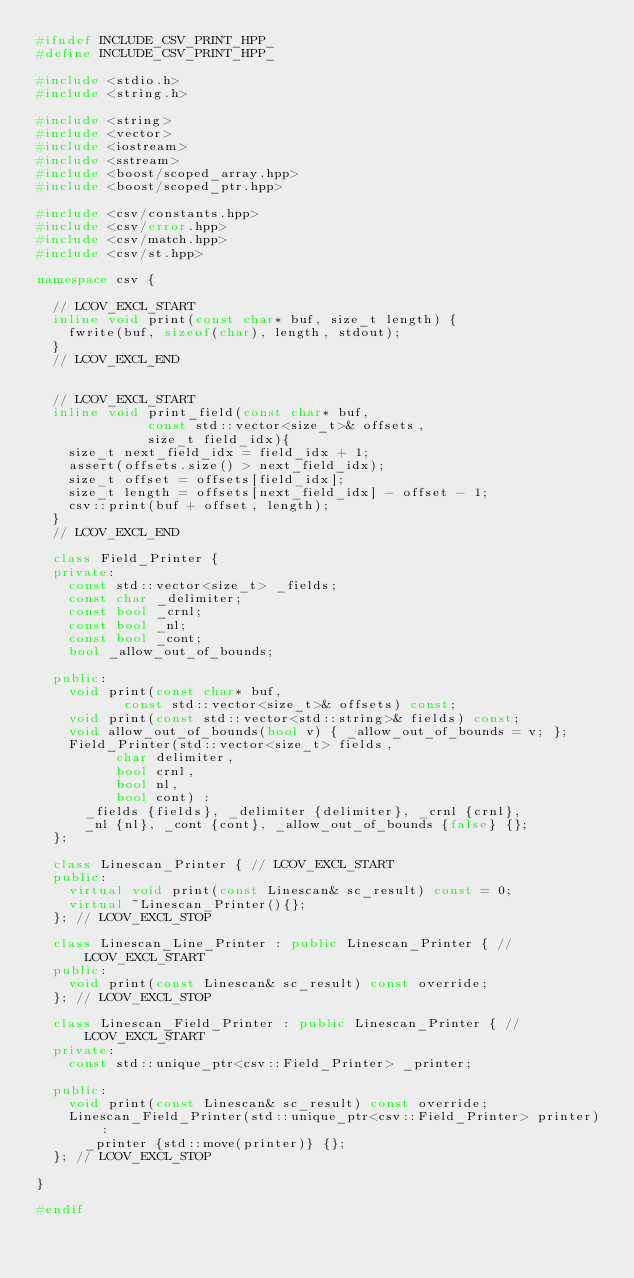Convert code to text. <code><loc_0><loc_0><loc_500><loc_500><_C++_>#ifndef INCLUDE_CSV_PRINT_HPP_
#define INCLUDE_CSV_PRINT_HPP_

#include <stdio.h>
#include <string.h>

#include <string>
#include <vector>
#include <iostream>
#include <sstream>
#include <boost/scoped_array.hpp>
#include <boost/scoped_ptr.hpp>

#include <csv/constants.hpp>
#include <csv/error.hpp>
#include <csv/match.hpp>
#include <csv/st.hpp>

namespace csv {

  // LCOV_EXCL_START
  inline void print(const char* buf, size_t length) {
    fwrite(buf, sizeof(char), length, stdout);
  }
  // LCOV_EXCL_END
  

  // LCOV_EXCL_START
  inline void print_field(const char* buf,
			  const std::vector<size_t>& offsets,
			  size_t field_idx){
    size_t next_field_idx = field_idx + 1;
    assert(offsets.size() > next_field_idx);
    size_t offset = offsets[field_idx];
    size_t length = offsets[next_field_idx] - offset - 1;
    csv::print(buf + offset, length);
  }
  // LCOV_EXCL_END

  class Field_Printer {
  private:
    const std::vector<size_t> _fields;
    const char _delimiter;
    const bool _crnl;
    const bool _nl;
    const bool _cont;
    bool _allow_out_of_bounds;
    
  public:
    void print(const char* buf,
	       const std::vector<size_t>& offsets) const;
    void print(const std::vector<std::string>& fields) const;
    void allow_out_of_bounds(bool v) { _allow_out_of_bounds = v; };
    Field_Printer(std::vector<size_t> fields,
		  char delimiter,
		  bool crnl,
		  bool nl,
		  bool cont) :
      _fields {fields}, _delimiter {delimiter}, _crnl {crnl},
      _nl {nl}, _cont {cont}, _allow_out_of_bounds {false} {};
  };

  class Linescan_Printer { // LCOV_EXCL_START
  public:
    virtual void print(const Linescan& sc_result) const = 0;
    virtual ~Linescan_Printer(){};
  }; // LCOV_EXCL_STOP

  class Linescan_Line_Printer : public Linescan_Printer { // LCOV_EXCL_START
  public:
    void print(const Linescan& sc_result) const override;
  }; // LCOV_EXCL_STOP

  class Linescan_Field_Printer : public Linescan_Printer { // LCOV_EXCL_START
  private:
    const std::unique_ptr<csv::Field_Printer> _printer;

  public:
    void print(const Linescan& sc_result) const override;
    Linescan_Field_Printer(std::unique_ptr<csv::Field_Printer> printer) :
      _printer {std::move(printer)} {};   
  }; // LCOV_EXCL_STOP

}

#endif
</code> 